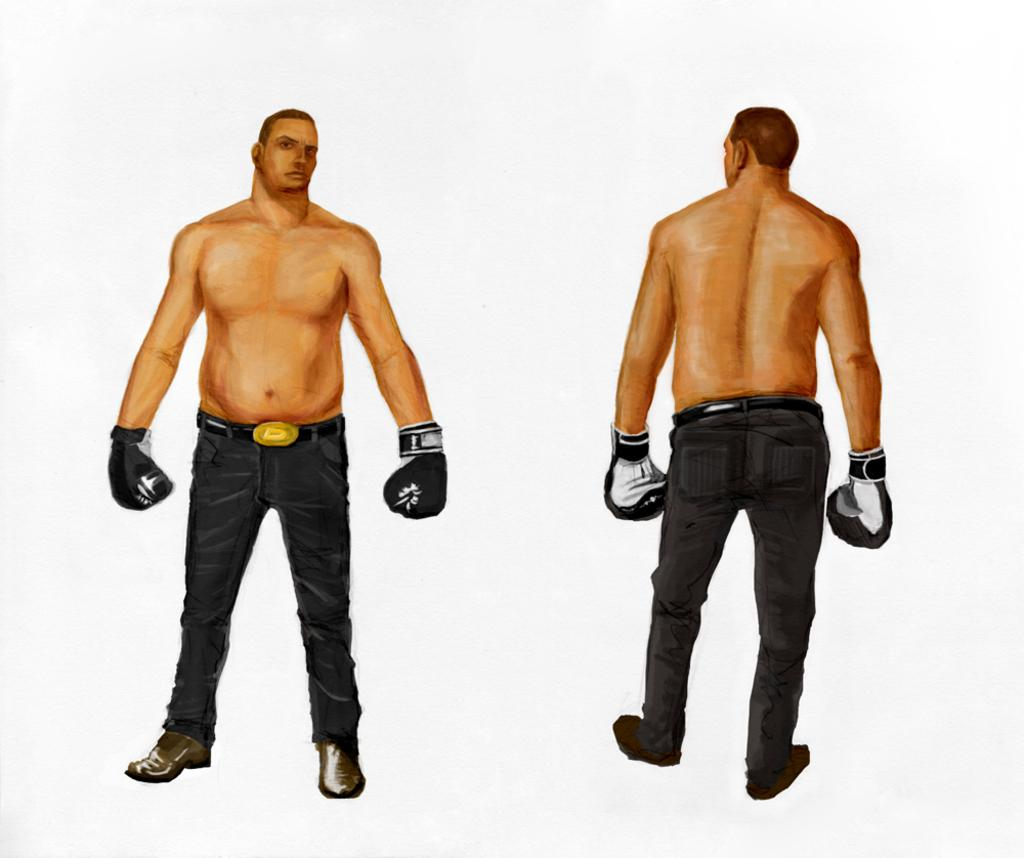How many people are in the image? There are two men in the image. What are the men doing in the image? The men are standing. What type of footwear are the men wearing? The men are wearing shoes. What type of hand covering are the men wearing? The men are wearing gloves. What type of lower body clothing are the men wearing? The men are wearing trousers. What type of drum can be seen in the image? There is no drum present in the image. Is there a sink visible in the image? There is no sink visible in the image. 